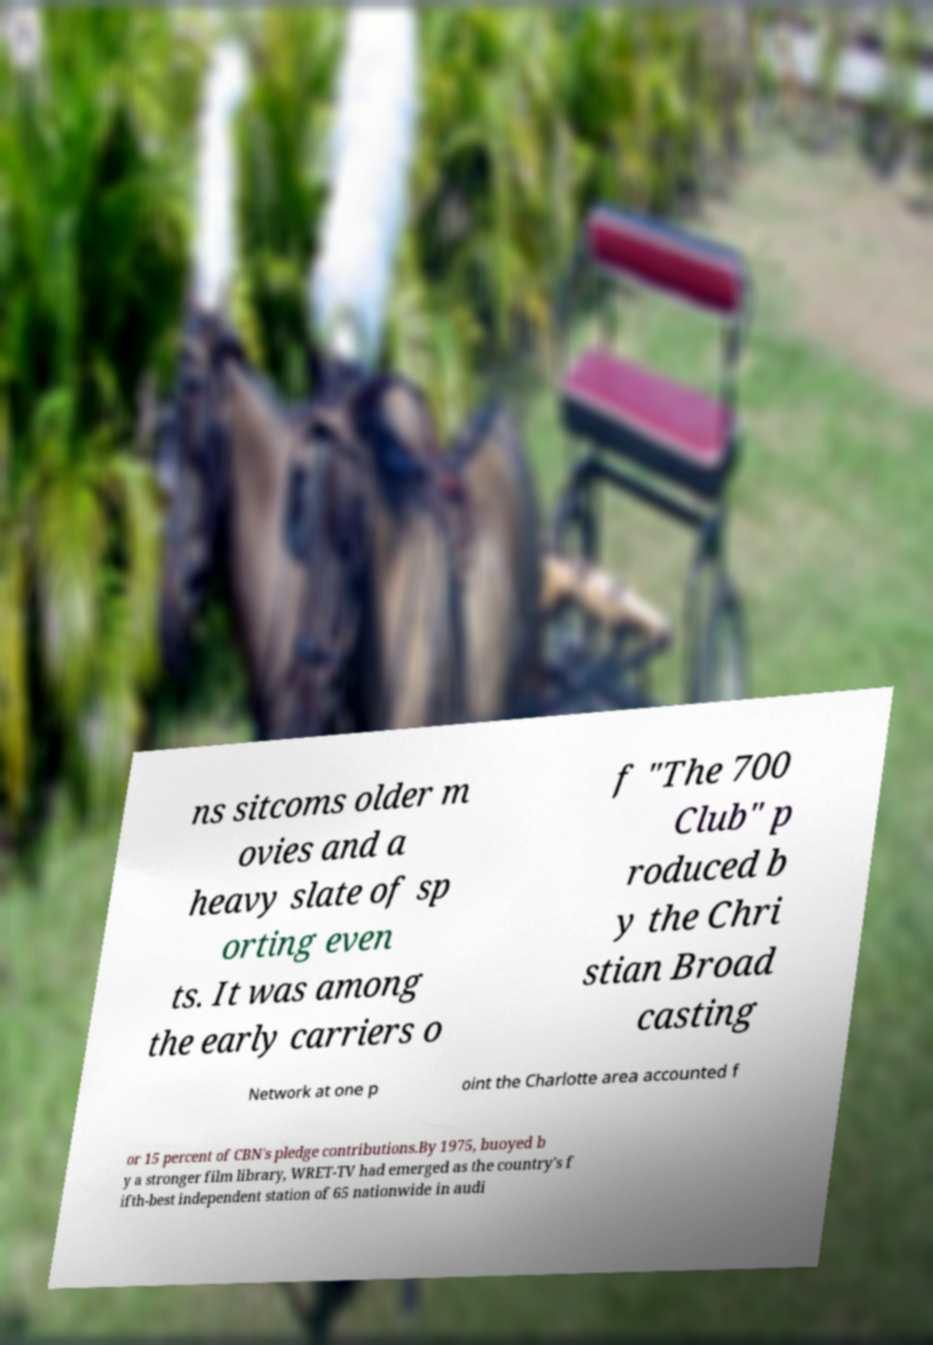For documentation purposes, I need the text within this image transcribed. Could you provide that? ns sitcoms older m ovies and a heavy slate of sp orting even ts. It was among the early carriers o f "The 700 Club" p roduced b y the Chri stian Broad casting Network at one p oint the Charlotte area accounted f or 15 percent of CBN's pledge contributions.By 1975, buoyed b y a stronger film library, WRET-TV had emerged as the country's f ifth-best independent station of 65 nationwide in audi 